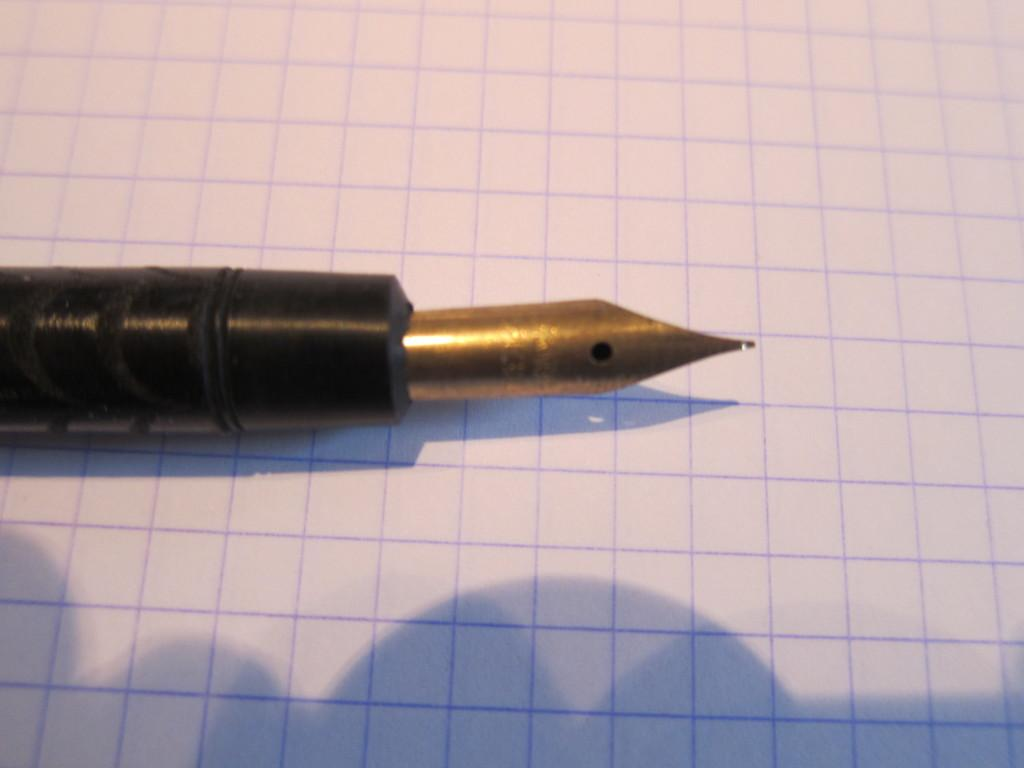What is the main object visible in the image? There is a pen in the image. Can you describe the position of the pen in the image? The pen is positioned above an object in the image. What type of birthday decoration is hanging from the pen in the image? There is no birthday decoration or any decoration mentioned in the image; it only contains a pen and an object below it. Can you tell me how many leaves are visible on the pen in the image? There are no leaves present in the image; it only contains a pen and an object below it. 